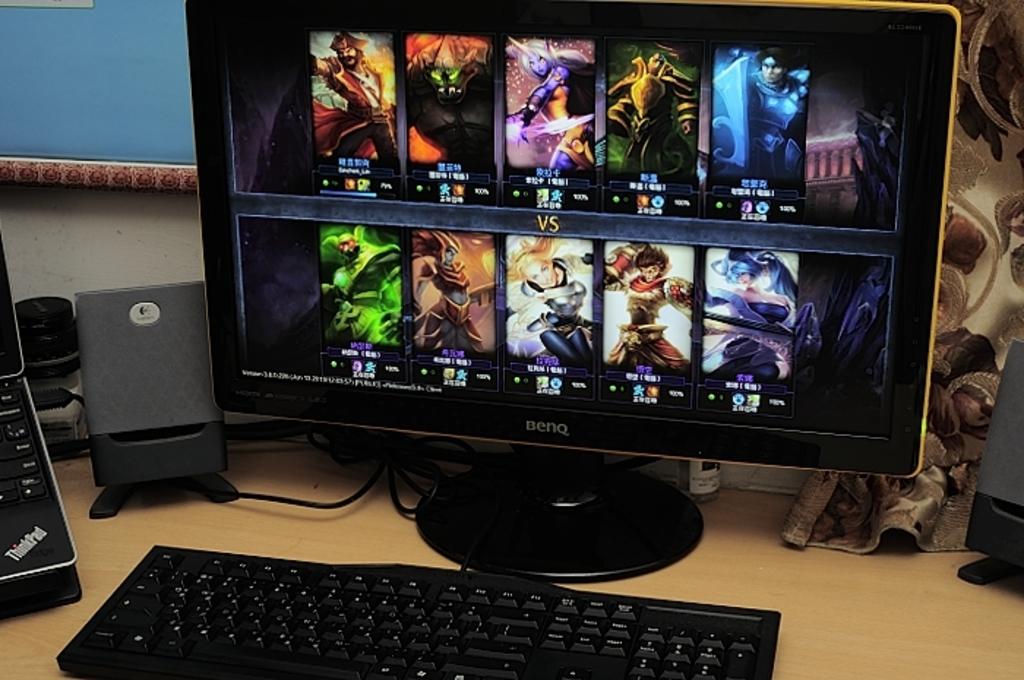What brand name is on the monitor?
Your answer should be very brief. Benq. What kind of laptop is off to the left?
Keep it short and to the point. Thinkpad. 